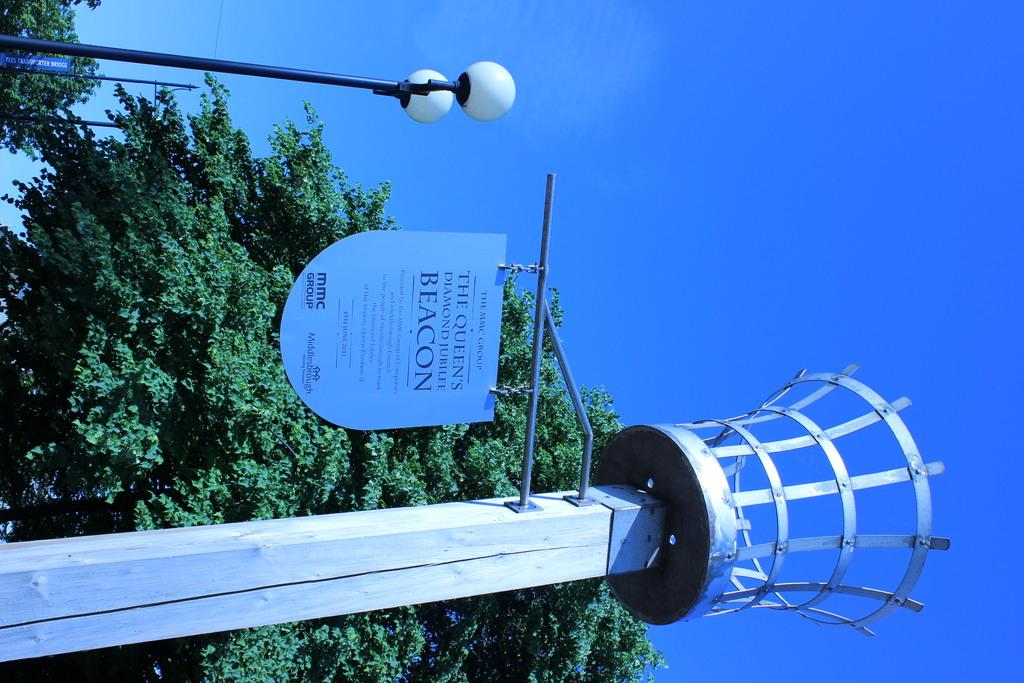What type of vegetation is on the left side of the image? There are trees on the left side of the image. What structures are located on the left side of the image? There is a street lamp, a tower, and a sign board on the left side of the image. What color is the sky in the background of the image? The sky is blue in the background of the image. What statement is being taught by the tower in the image? There is no teaching or statement being conveyed by the tower in the image; it is a structure with no apparent educational or communicative purpose. 